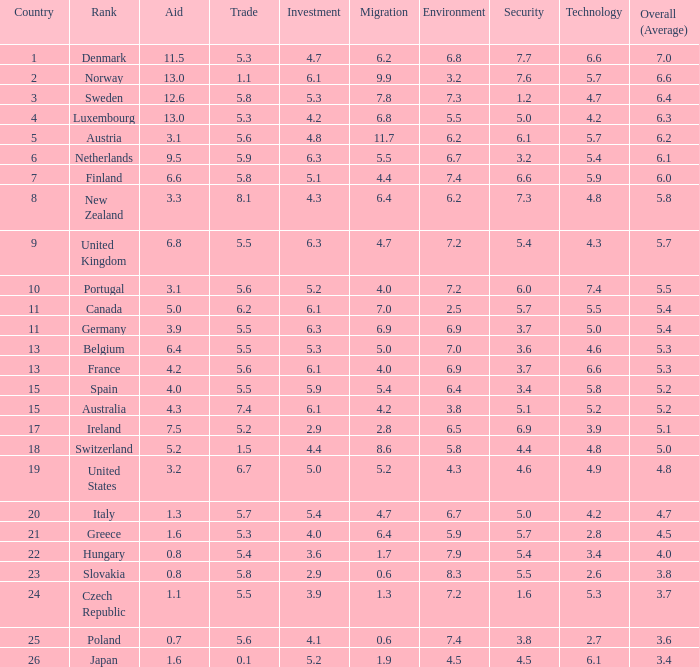Would you mind parsing the complete table? {'header': ['Country', 'Rank', 'Aid', 'Trade', 'Investment', 'Migration', 'Environment', 'Security', 'Technology', 'Overall (Average)'], 'rows': [['1', 'Denmark', '11.5', '5.3', '4.7', '6.2', '6.8', '7.7', '6.6', '7.0'], ['2', 'Norway', '13.0', '1.1', '6.1', '9.9', '3.2', '7.6', '5.7', '6.6'], ['3', 'Sweden', '12.6', '5.8', '5.3', '7.8', '7.3', '1.2', '4.7', '6.4'], ['4', 'Luxembourg', '13.0', '5.3', '4.2', '6.8', '5.5', '5.0', '4.2', '6.3'], ['5', 'Austria', '3.1', '5.6', '4.8', '11.7', '6.2', '6.1', '5.7', '6.2'], ['6', 'Netherlands', '9.5', '5.9', '6.3', '5.5', '6.7', '3.2', '5.4', '6.1'], ['7', 'Finland', '6.6', '5.8', '5.1', '4.4', '7.4', '6.6', '5.9', '6.0'], ['8', 'New Zealand', '3.3', '8.1', '4.3', '6.4', '6.2', '7.3', '4.8', '5.8'], ['9', 'United Kingdom', '6.8', '5.5', '6.3', '4.7', '7.2', '5.4', '4.3', '5.7'], ['10', 'Portugal', '3.1', '5.6', '5.2', '4.0', '7.2', '6.0', '7.4', '5.5'], ['11', 'Canada', '5.0', '6.2', '6.1', '7.0', '2.5', '5.7', '5.5', '5.4'], ['11', 'Germany', '3.9', '5.5', '6.3', '6.9', '6.9', '3.7', '5.0', '5.4'], ['13', 'Belgium', '6.4', '5.5', '5.3', '5.0', '7.0', '3.6', '4.6', '5.3'], ['13', 'France', '4.2', '5.6', '6.1', '4.0', '6.9', '3.7', '6.6', '5.3'], ['15', 'Spain', '4.0', '5.5', '5.9', '5.4', '6.4', '3.4', '5.8', '5.2'], ['15', 'Australia', '4.3', '7.4', '6.1', '4.2', '3.8', '5.1', '5.2', '5.2'], ['17', 'Ireland', '7.5', '5.2', '2.9', '2.8', '6.5', '6.9', '3.9', '5.1'], ['18', 'Switzerland', '5.2', '1.5', '4.4', '8.6', '5.8', '4.4', '4.8', '5.0'], ['19', 'United States', '3.2', '6.7', '5.0', '5.2', '4.3', '4.6', '4.9', '4.8'], ['20', 'Italy', '1.3', '5.7', '5.4', '4.7', '6.7', '5.0', '4.2', '4.7'], ['21', 'Greece', '1.6', '5.3', '4.0', '6.4', '5.9', '5.7', '2.8', '4.5'], ['22', 'Hungary', '0.8', '5.4', '3.6', '1.7', '7.9', '5.4', '3.4', '4.0'], ['23', 'Slovakia', '0.8', '5.8', '2.9', '0.6', '8.3', '5.5', '2.6', '3.8'], ['24', 'Czech Republic', '1.1', '5.5', '3.9', '1.3', '7.2', '1.6', '5.3', '3.7'], ['25', 'Poland', '0.7', '5.6', '4.1', '0.6', '7.4', '3.8', '2.7', '3.6'], ['26', 'Japan', '1.6', '0.1', '5.2', '1.9', '4.5', '4.5', '6.1', '3.4']]} What is the environment rating of the country with an overall average rating of 4.7? 6.7. 